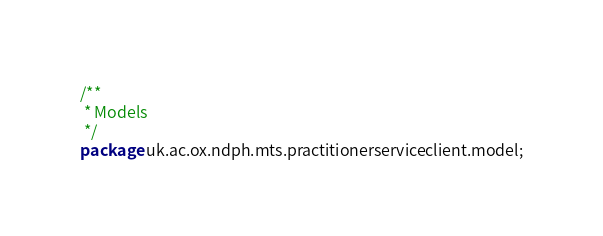<code> <loc_0><loc_0><loc_500><loc_500><_Java_>/**
 * Models
 */
package uk.ac.ox.ndph.mts.practitionerserviceclient.model;
</code> 